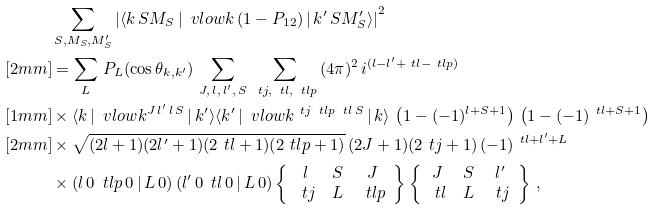<formula> <loc_0><loc_0><loc_500><loc_500>& \sum _ { S , M _ { S } , M ^ { \prime } _ { S } } \left | \langle { k } \, S M _ { S } \, | \, \ v l o w k \, ( 1 - P _ { 1 2 } ) \, | \, { k ^ { \prime } } \, S M ^ { \prime } _ { S } \rangle \right | ^ { 2 } \\ [ 2 m m ] & = \sum _ { L } \, P _ { L } ( \cos \theta _ { { k } , { k ^ { \prime } } } ) \, \sum _ { J , \, l , \, l ^ { \prime } , \, S } \, \sum _ { \ t j , \, \ t l , \, \ t l p } \, ( 4 \pi ) ^ { 2 } \, i ^ { ( l - l ^ { \prime } + \ t l - \ t l p ) } \\ [ 1 m m ] & \times \langle k \, | \, \ v l o w k ^ { J \, l ^ { \prime } \, l \, S } \, | \, k ^ { \prime } \rangle \langle k ^ { \prime } \, | \, \ v l o w k ^ { \ t j \, \ t l p \, \ t l \, S } \, | \, k \rangle \, \left ( 1 - ( - 1 ) ^ { l + S + 1 } \right ) \, \left ( 1 - ( - 1 ) ^ { \ t l + S + 1 } \right ) \\ [ 2 m m ] & \times \sqrt { ( 2 l + 1 ) ( 2 l ^ { \prime } + 1 ) ( 2 \ t l + 1 ) ( 2 \ t l p + 1 ) } \, ( 2 J + 1 ) ( 2 \ t j + 1 ) \, ( - 1 ) ^ { \ t l + l ^ { \prime } + L } \\ & \times \left ( l \, 0 \, \ t l p \, 0 \, | \, L \, 0 \right ) \left ( l ^ { \prime } \, 0 \, \ t l \, 0 \, | \, L \, 0 \right ) \left \{ \begin{array} { c c c } l & S & J \\ \ t j & L & \ t l p \end{array} \right \} \left \{ \begin{array} { c c c } J & S & l ^ { \prime } \\ \ t l & L & \ t j \end{array} \right \} \, ,</formula> 